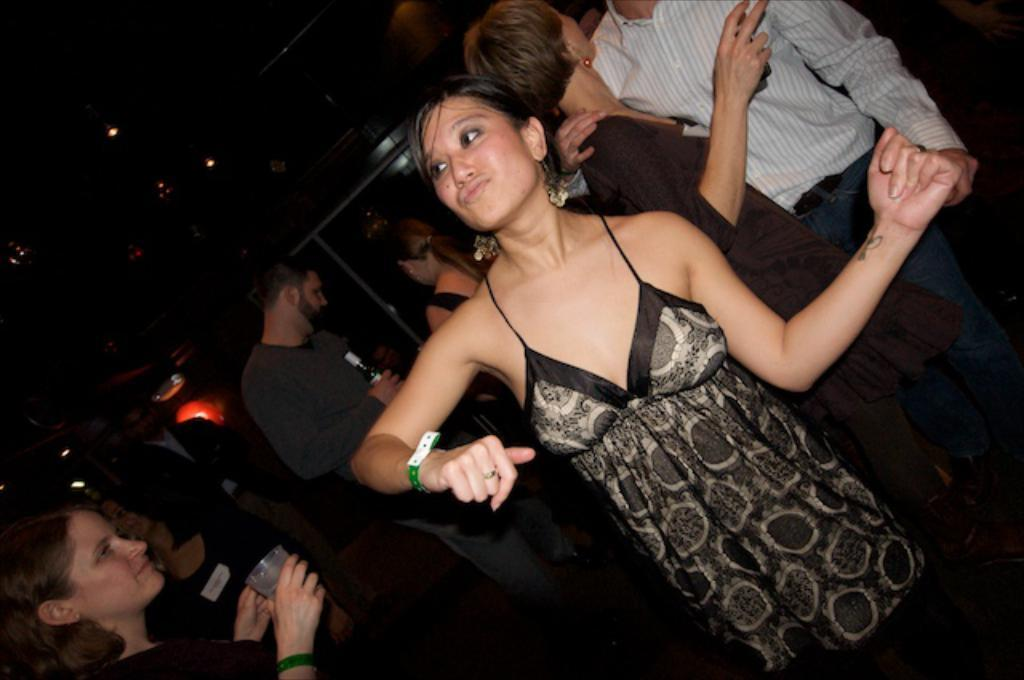Who is present in the image? There are people in the image. What are the people doing in the image? The people are drinking wine and holding bottles and wine glasses. Can you describe the woman in the image? The woman is in the image, and she is dancing. What can be seen in the background of the image? There are lights visible in the image. What type of bat is flying around in the image? There is no bat present in the image. What holiday is being celebrated in the image? The image does not depict a specific holiday. 